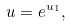<formula> <loc_0><loc_0><loc_500><loc_500>u = e ^ { u _ { 1 } } ,</formula> 